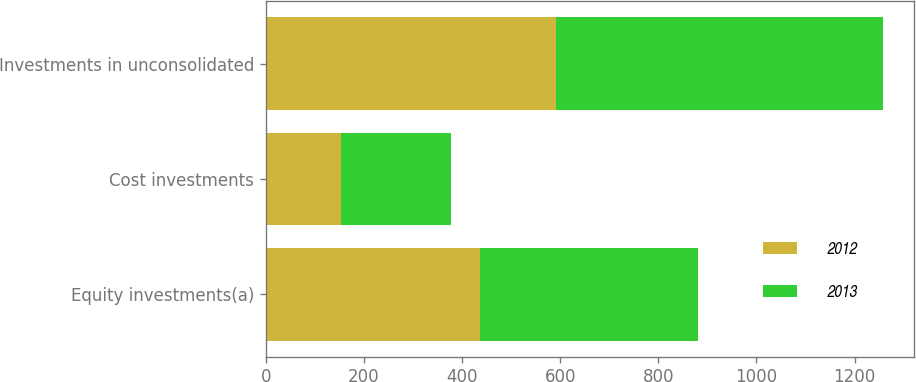<chart> <loc_0><loc_0><loc_500><loc_500><stacked_bar_chart><ecel><fcel>Equity investments(a)<fcel>Cost investments<fcel>Investments in unconsolidated<nl><fcel>2012<fcel>437<fcel>154<fcel>591<nl><fcel>2013<fcel>443<fcel>224<fcel>667<nl></chart> 